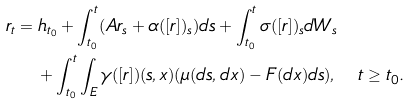<formula> <loc_0><loc_0><loc_500><loc_500>r _ { t } & = h _ { t _ { 0 } } + \int _ { t _ { 0 } } ^ { t } ( A r _ { s } + \alpha ( [ r ] ) _ { s } ) d s + \int _ { t _ { 0 } } ^ { t } \sigma ( [ r ] ) _ { s } d W _ { s } \\ & \quad + \int _ { t _ { 0 } } ^ { t } \int _ { E } \gamma ( [ r ] ) ( s , x ) ( \mu ( d s , d x ) - F ( d x ) d s ) , \quad t \geq t _ { 0 } .</formula> 